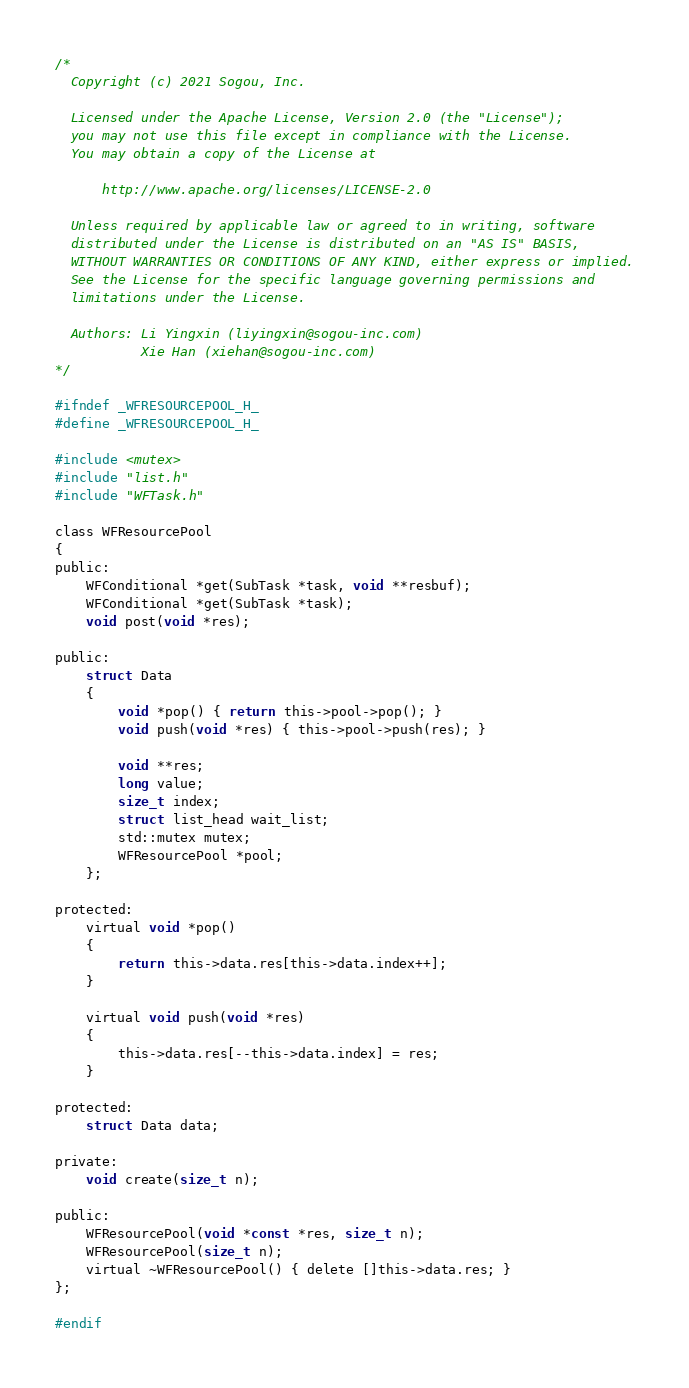<code> <loc_0><loc_0><loc_500><loc_500><_C_>/*
  Copyright (c) 2021 Sogou, Inc.

  Licensed under the Apache License, Version 2.0 (the "License");
  you may not use this file except in compliance with the License.
  You may obtain a copy of the License at

      http://www.apache.org/licenses/LICENSE-2.0

  Unless required by applicable law or agreed to in writing, software
  distributed under the License is distributed on an "AS IS" BASIS,
  WITHOUT WARRANTIES OR CONDITIONS OF ANY KIND, either express or implied.
  See the License for the specific language governing permissions and
  limitations under the License.

  Authors: Li Yingxin (liyingxin@sogou-inc.com)
           Xie Han (xiehan@sogou-inc.com)
*/

#ifndef _WFRESOURCEPOOL_H_
#define _WFRESOURCEPOOL_H_

#include <mutex>
#include "list.h"
#include "WFTask.h"

class WFResourcePool
{
public:
	WFConditional *get(SubTask *task, void **resbuf);
	WFConditional *get(SubTask *task);
	void post(void *res);

public:
	struct Data
	{
		void *pop() { return this->pool->pop(); }
		void push(void *res) { this->pool->push(res); }

		void **res;
		long value;
		size_t index;
		struct list_head wait_list;
		std::mutex mutex;
		WFResourcePool *pool;
	};

protected:
	virtual void *pop()
	{
		return this->data.res[this->data.index++];
	}

	virtual void push(void *res)
	{
		this->data.res[--this->data.index] = res;
	}

protected:
	struct Data data;

private:
	void create(size_t n);

public:
	WFResourcePool(void *const *res, size_t n);
	WFResourcePool(size_t n);
	virtual ~WFResourcePool() { delete []this->data.res; }
};

#endif

</code> 